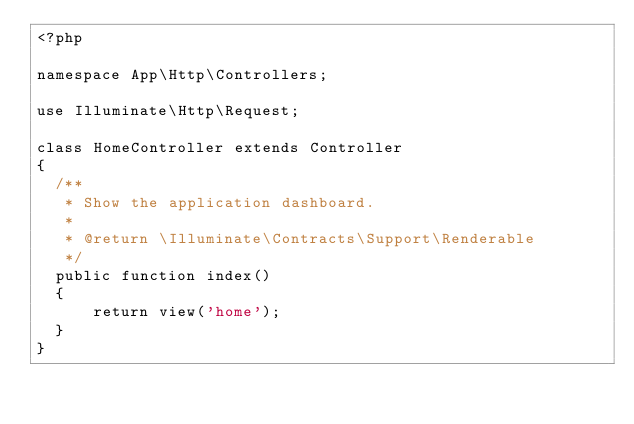Convert code to text. <code><loc_0><loc_0><loc_500><loc_500><_PHP_><?php

namespace App\Http\Controllers;

use Illuminate\Http\Request;

class HomeController extends Controller
{
  /**
   * Show the application dashboard.
   *
   * @return \Illuminate\Contracts\Support\Renderable
   */
  public function index()
  {
      return view('home');
  }
}
</code> 